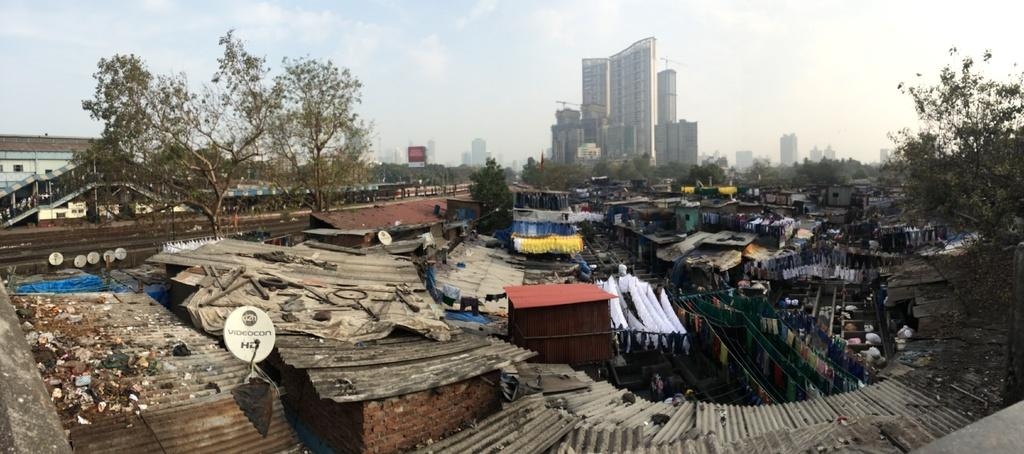What type of structures can be seen in the image? There are sheds in the image. What can be seen in the background of the image? There are trees in the background of the image. What is the color of the trees? The trees are green. What other type of structure is present in the image? There is a building in the image. What is the color of the building? The building is white. What is visible above the structures in the image? The sky is visible in the image. What colors can be seen in the sky? The sky has both white and blue colors. How does the toe feel about the journey depicted in the image? There is no toe or journey present in the image; it only features sheds, trees, a building, and the sky. 